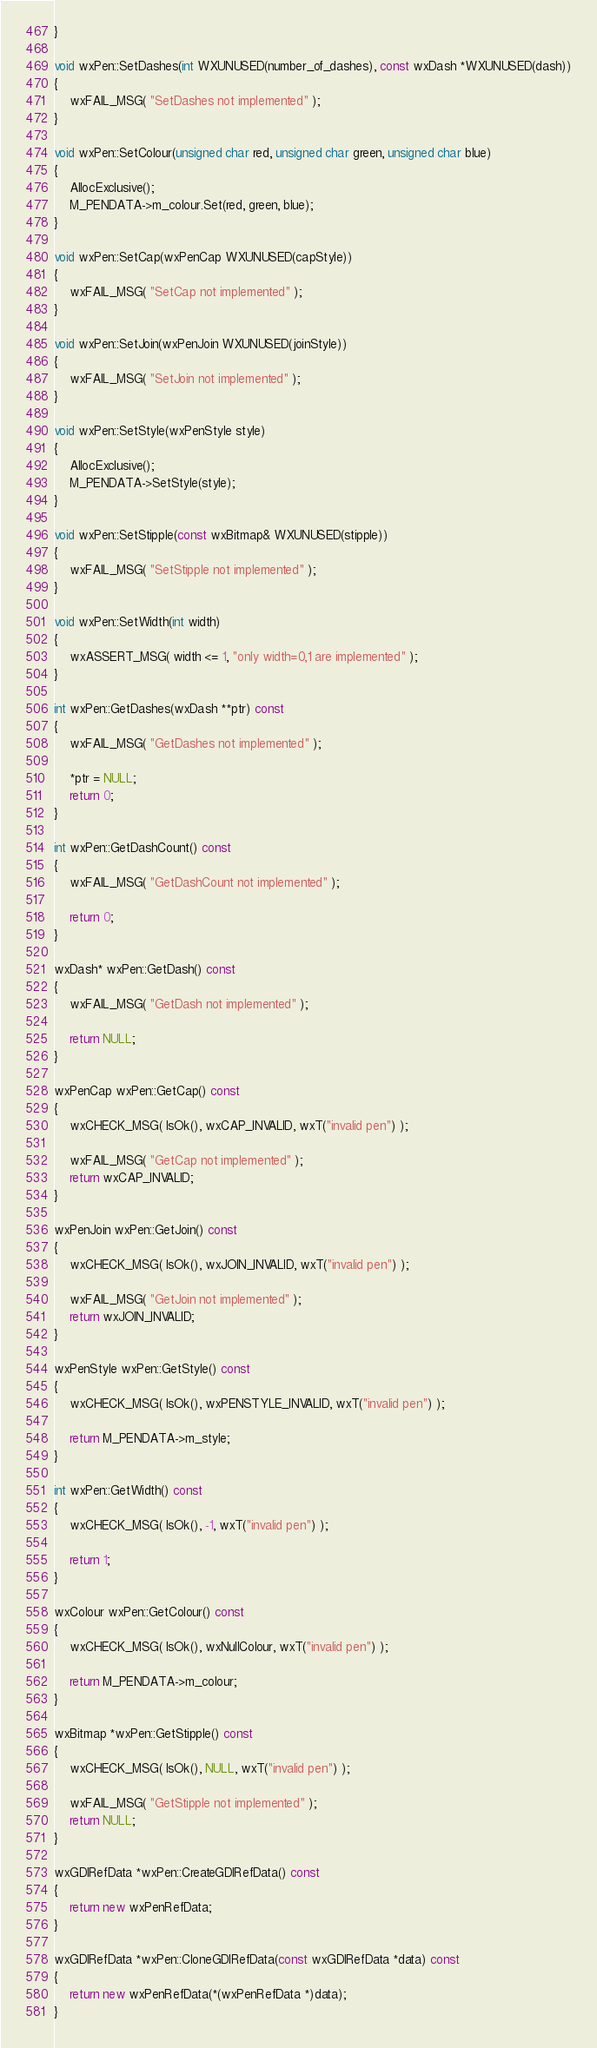<code> <loc_0><loc_0><loc_500><loc_500><_C++_>}

void wxPen::SetDashes(int WXUNUSED(number_of_dashes), const wxDash *WXUNUSED(dash))
{
    wxFAIL_MSG( "SetDashes not implemented" );
}

void wxPen::SetColour(unsigned char red, unsigned char green, unsigned char blue)
{
    AllocExclusive();
    M_PENDATA->m_colour.Set(red, green, blue);
}

void wxPen::SetCap(wxPenCap WXUNUSED(capStyle))
{
    wxFAIL_MSG( "SetCap not implemented" );
}

void wxPen::SetJoin(wxPenJoin WXUNUSED(joinStyle))
{
    wxFAIL_MSG( "SetJoin not implemented" );
}

void wxPen::SetStyle(wxPenStyle style)
{
    AllocExclusive();
    M_PENDATA->SetStyle(style);
}

void wxPen::SetStipple(const wxBitmap& WXUNUSED(stipple))
{
    wxFAIL_MSG( "SetStipple not implemented" );
}

void wxPen::SetWidth(int width)
{
    wxASSERT_MSG( width <= 1, "only width=0,1 are implemented" );
}

int wxPen::GetDashes(wxDash **ptr) const
{
    wxFAIL_MSG( "GetDashes not implemented" );

    *ptr = NULL;
    return 0;
}

int wxPen::GetDashCount() const
{
    wxFAIL_MSG( "GetDashCount not implemented" );

    return 0;
}

wxDash* wxPen::GetDash() const
{
    wxFAIL_MSG( "GetDash not implemented" );

    return NULL;
}

wxPenCap wxPen::GetCap() const
{
    wxCHECK_MSG( IsOk(), wxCAP_INVALID, wxT("invalid pen") );

    wxFAIL_MSG( "GetCap not implemented" );
    return wxCAP_INVALID;
}

wxPenJoin wxPen::GetJoin() const
{
    wxCHECK_MSG( IsOk(), wxJOIN_INVALID, wxT("invalid pen") );

    wxFAIL_MSG( "GetJoin not implemented" );
    return wxJOIN_INVALID;
}

wxPenStyle wxPen::GetStyle() const
{
    wxCHECK_MSG( IsOk(), wxPENSTYLE_INVALID, wxT("invalid pen") );

    return M_PENDATA->m_style;
}

int wxPen::GetWidth() const
{
    wxCHECK_MSG( IsOk(), -1, wxT("invalid pen") );

    return 1;
}

wxColour wxPen::GetColour() const
{
    wxCHECK_MSG( IsOk(), wxNullColour, wxT("invalid pen") );

    return M_PENDATA->m_colour;
}

wxBitmap *wxPen::GetStipple() const
{
    wxCHECK_MSG( IsOk(), NULL, wxT("invalid pen") );

    wxFAIL_MSG( "GetStipple not implemented" );
    return NULL;
}

wxGDIRefData *wxPen::CreateGDIRefData() const
{
    return new wxPenRefData;
}

wxGDIRefData *wxPen::CloneGDIRefData(const wxGDIRefData *data) const
{
    return new wxPenRefData(*(wxPenRefData *)data);
}
</code> 